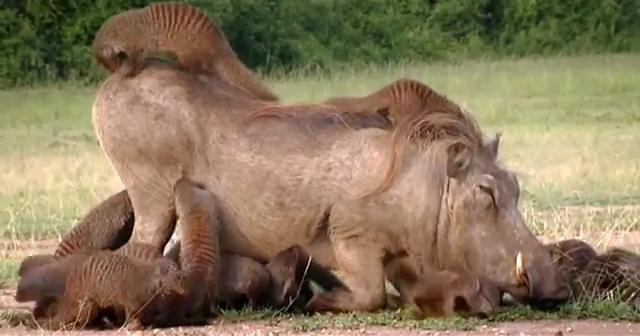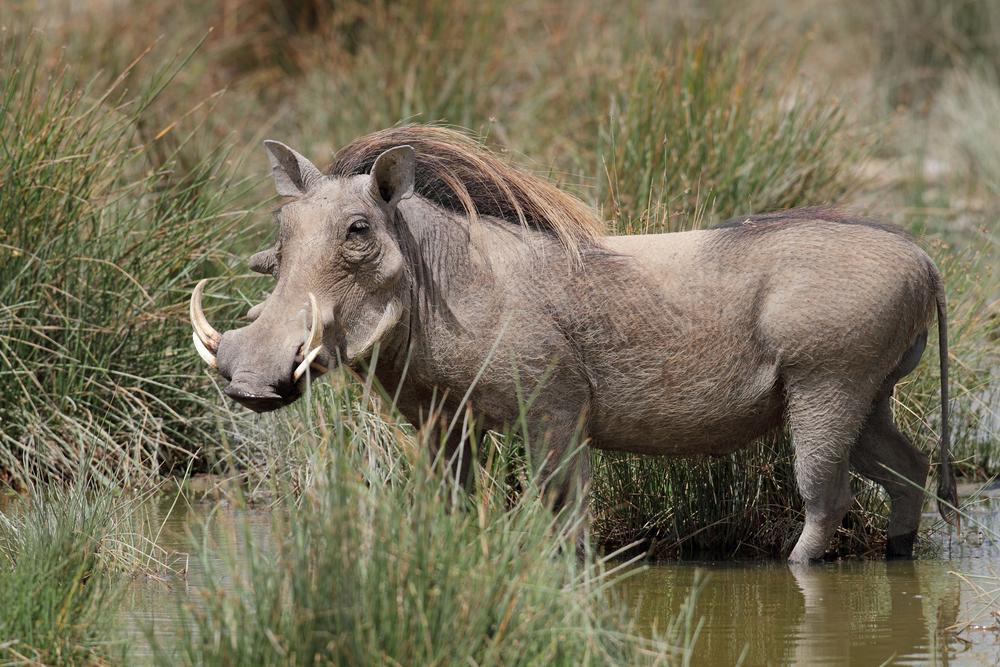The first image is the image on the left, the second image is the image on the right. Evaluate the accuracy of this statement regarding the images: "There are no more than two boars with tusks.". Is it true? Answer yes or no. Yes. The first image is the image on the left, the second image is the image on the right. For the images displayed, is the sentence "An image includes a warthog that is standing with its front knees on the ground." factually correct? Answer yes or no. Yes. 